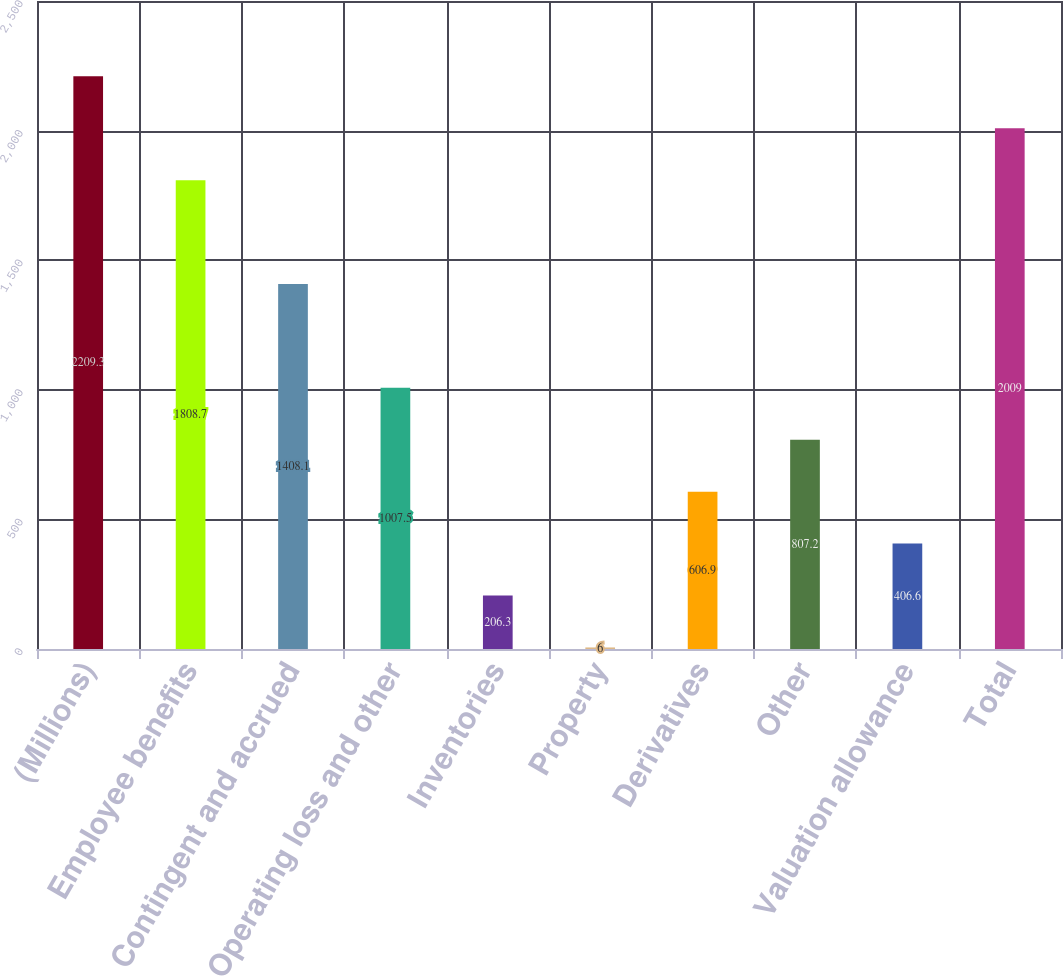<chart> <loc_0><loc_0><loc_500><loc_500><bar_chart><fcel>(Millions)<fcel>Employee benefits<fcel>Contingent and accrued<fcel>Operating loss and other<fcel>Inventories<fcel>Property<fcel>Derivatives<fcel>Other<fcel>Valuation allowance<fcel>Total<nl><fcel>2209.3<fcel>1808.7<fcel>1408.1<fcel>1007.5<fcel>206.3<fcel>6<fcel>606.9<fcel>807.2<fcel>406.6<fcel>2009<nl></chart> 